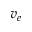Convert formula to latex. <formula><loc_0><loc_0><loc_500><loc_500>v _ { e }</formula> 